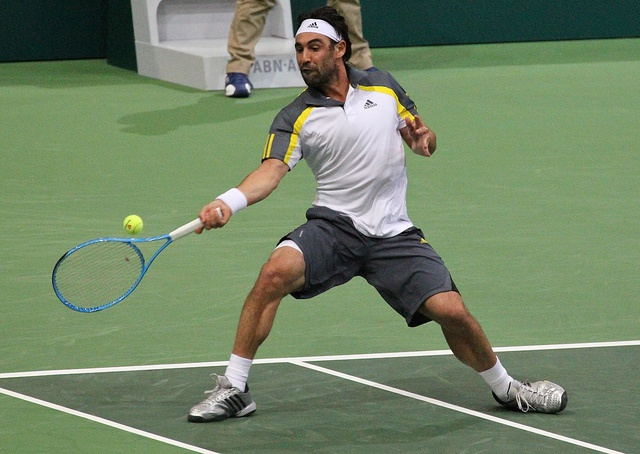Describe the objects in this image and their specific colors. I can see people in black, lavender, gray, and darkgray tones, tennis racket in black, olive, teal, and darkgray tones, people in black, darkgray, and gray tones, and sports ball in black, khaki, and olive tones in this image. 